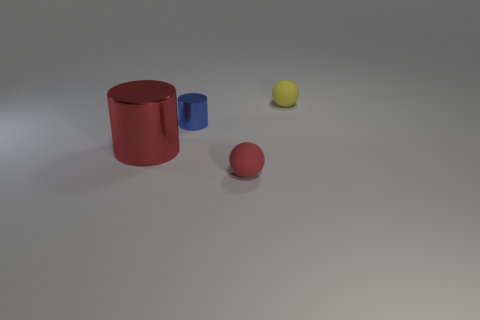There is a object that is in front of the blue object and on the right side of the large shiny cylinder; what size is it?
Your answer should be compact. Small. There is a big object that is left of the tiny blue object; what is its material?
Offer a terse response. Metal. There is a small cylinder; does it have the same color as the tiny rubber object that is in front of the big red object?
Provide a succinct answer. No. What number of things are either matte balls that are in front of the large metal object or objects that are behind the tiny red sphere?
Provide a short and direct response. 4. There is a object that is in front of the blue cylinder and to the right of the large red shiny object; what is its color?
Give a very brief answer. Red. Is the number of red matte objects greater than the number of small matte spheres?
Your response must be concise. No. Is the shape of the tiny blue object behind the large red cylinder the same as  the small red thing?
Your response must be concise. No. What number of matte things are either small blue cylinders or big cylinders?
Your response must be concise. 0. Are there any large brown cylinders that have the same material as the blue cylinder?
Give a very brief answer. No. What is the material of the large red cylinder?
Give a very brief answer. Metal. 